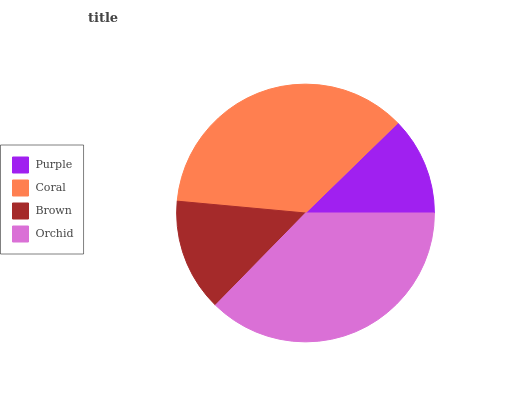Is Purple the minimum?
Answer yes or no. Yes. Is Orchid the maximum?
Answer yes or no. Yes. Is Coral the minimum?
Answer yes or no. No. Is Coral the maximum?
Answer yes or no. No. Is Coral greater than Purple?
Answer yes or no. Yes. Is Purple less than Coral?
Answer yes or no. Yes. Is Purple greater than Coral?
Answer yes or no. No. Is Coral less than Purple?
Answer yes or no. No. Is Coral the high median?
Answer yes or no. Yes. Is Brown the low median?
Answer yes or no. Yes. Is Orchid the high median?
Answer yes or no. No. Is Orchid the low median?
Answer yes or no. No. 